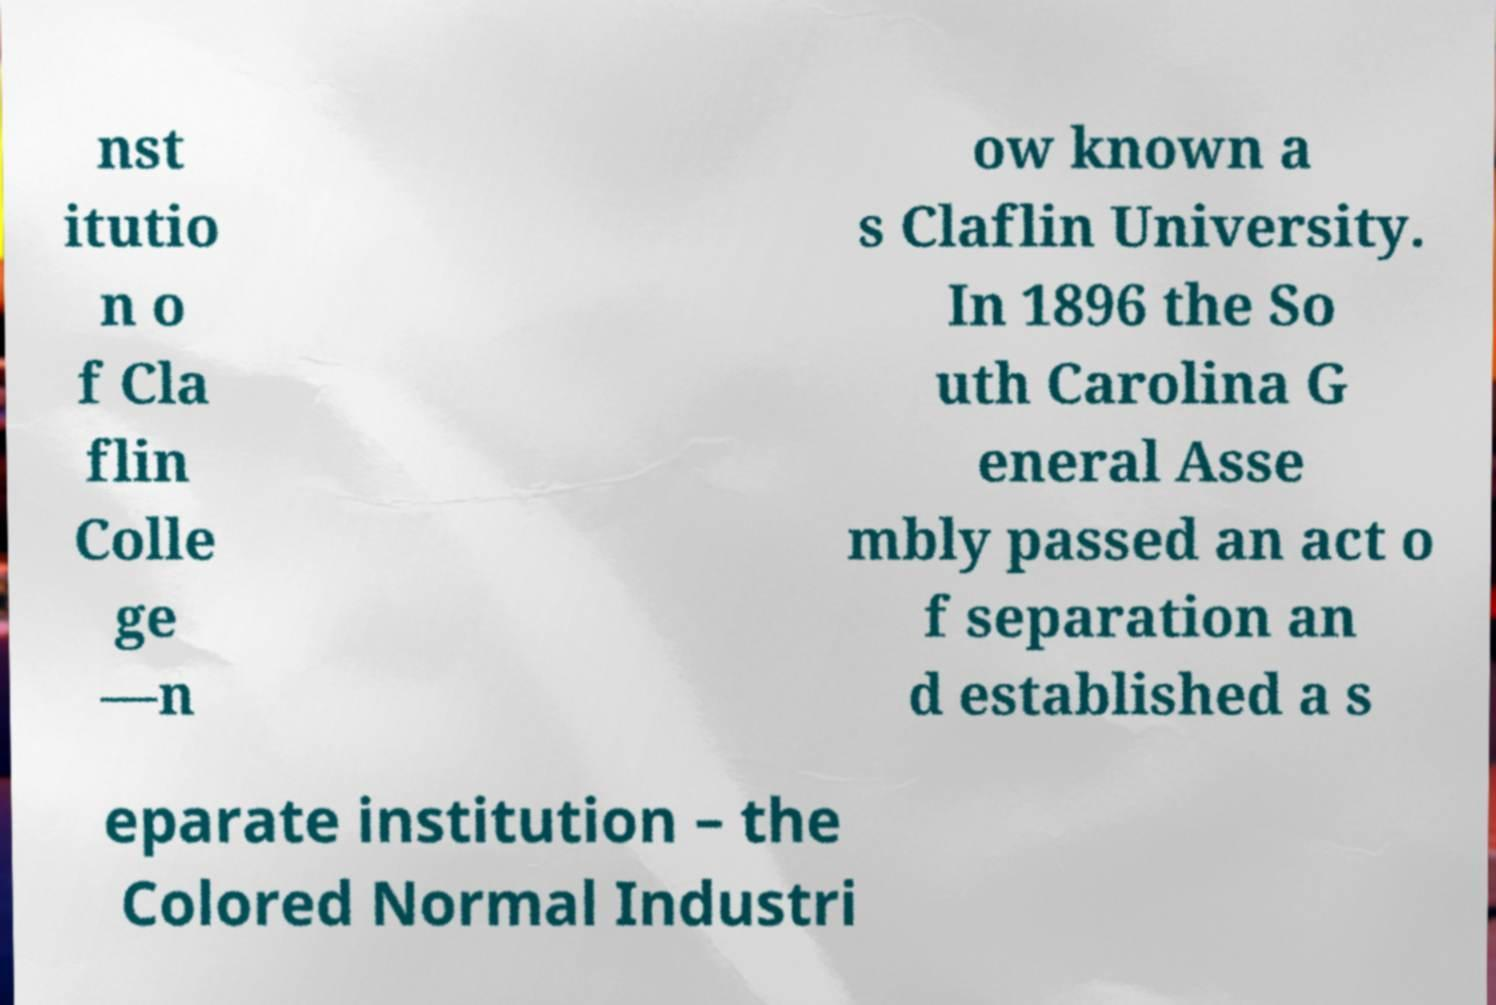I need the written content from this picture converted into text. Can you do that? nst itutio n o f Cla flin Colle ge —n ow known a s Claflin University. In 1896 the So uth Carolina G eneral Asse mbly passed an act o f separation an d established a s eparate institution – the Colored Normal Industri 